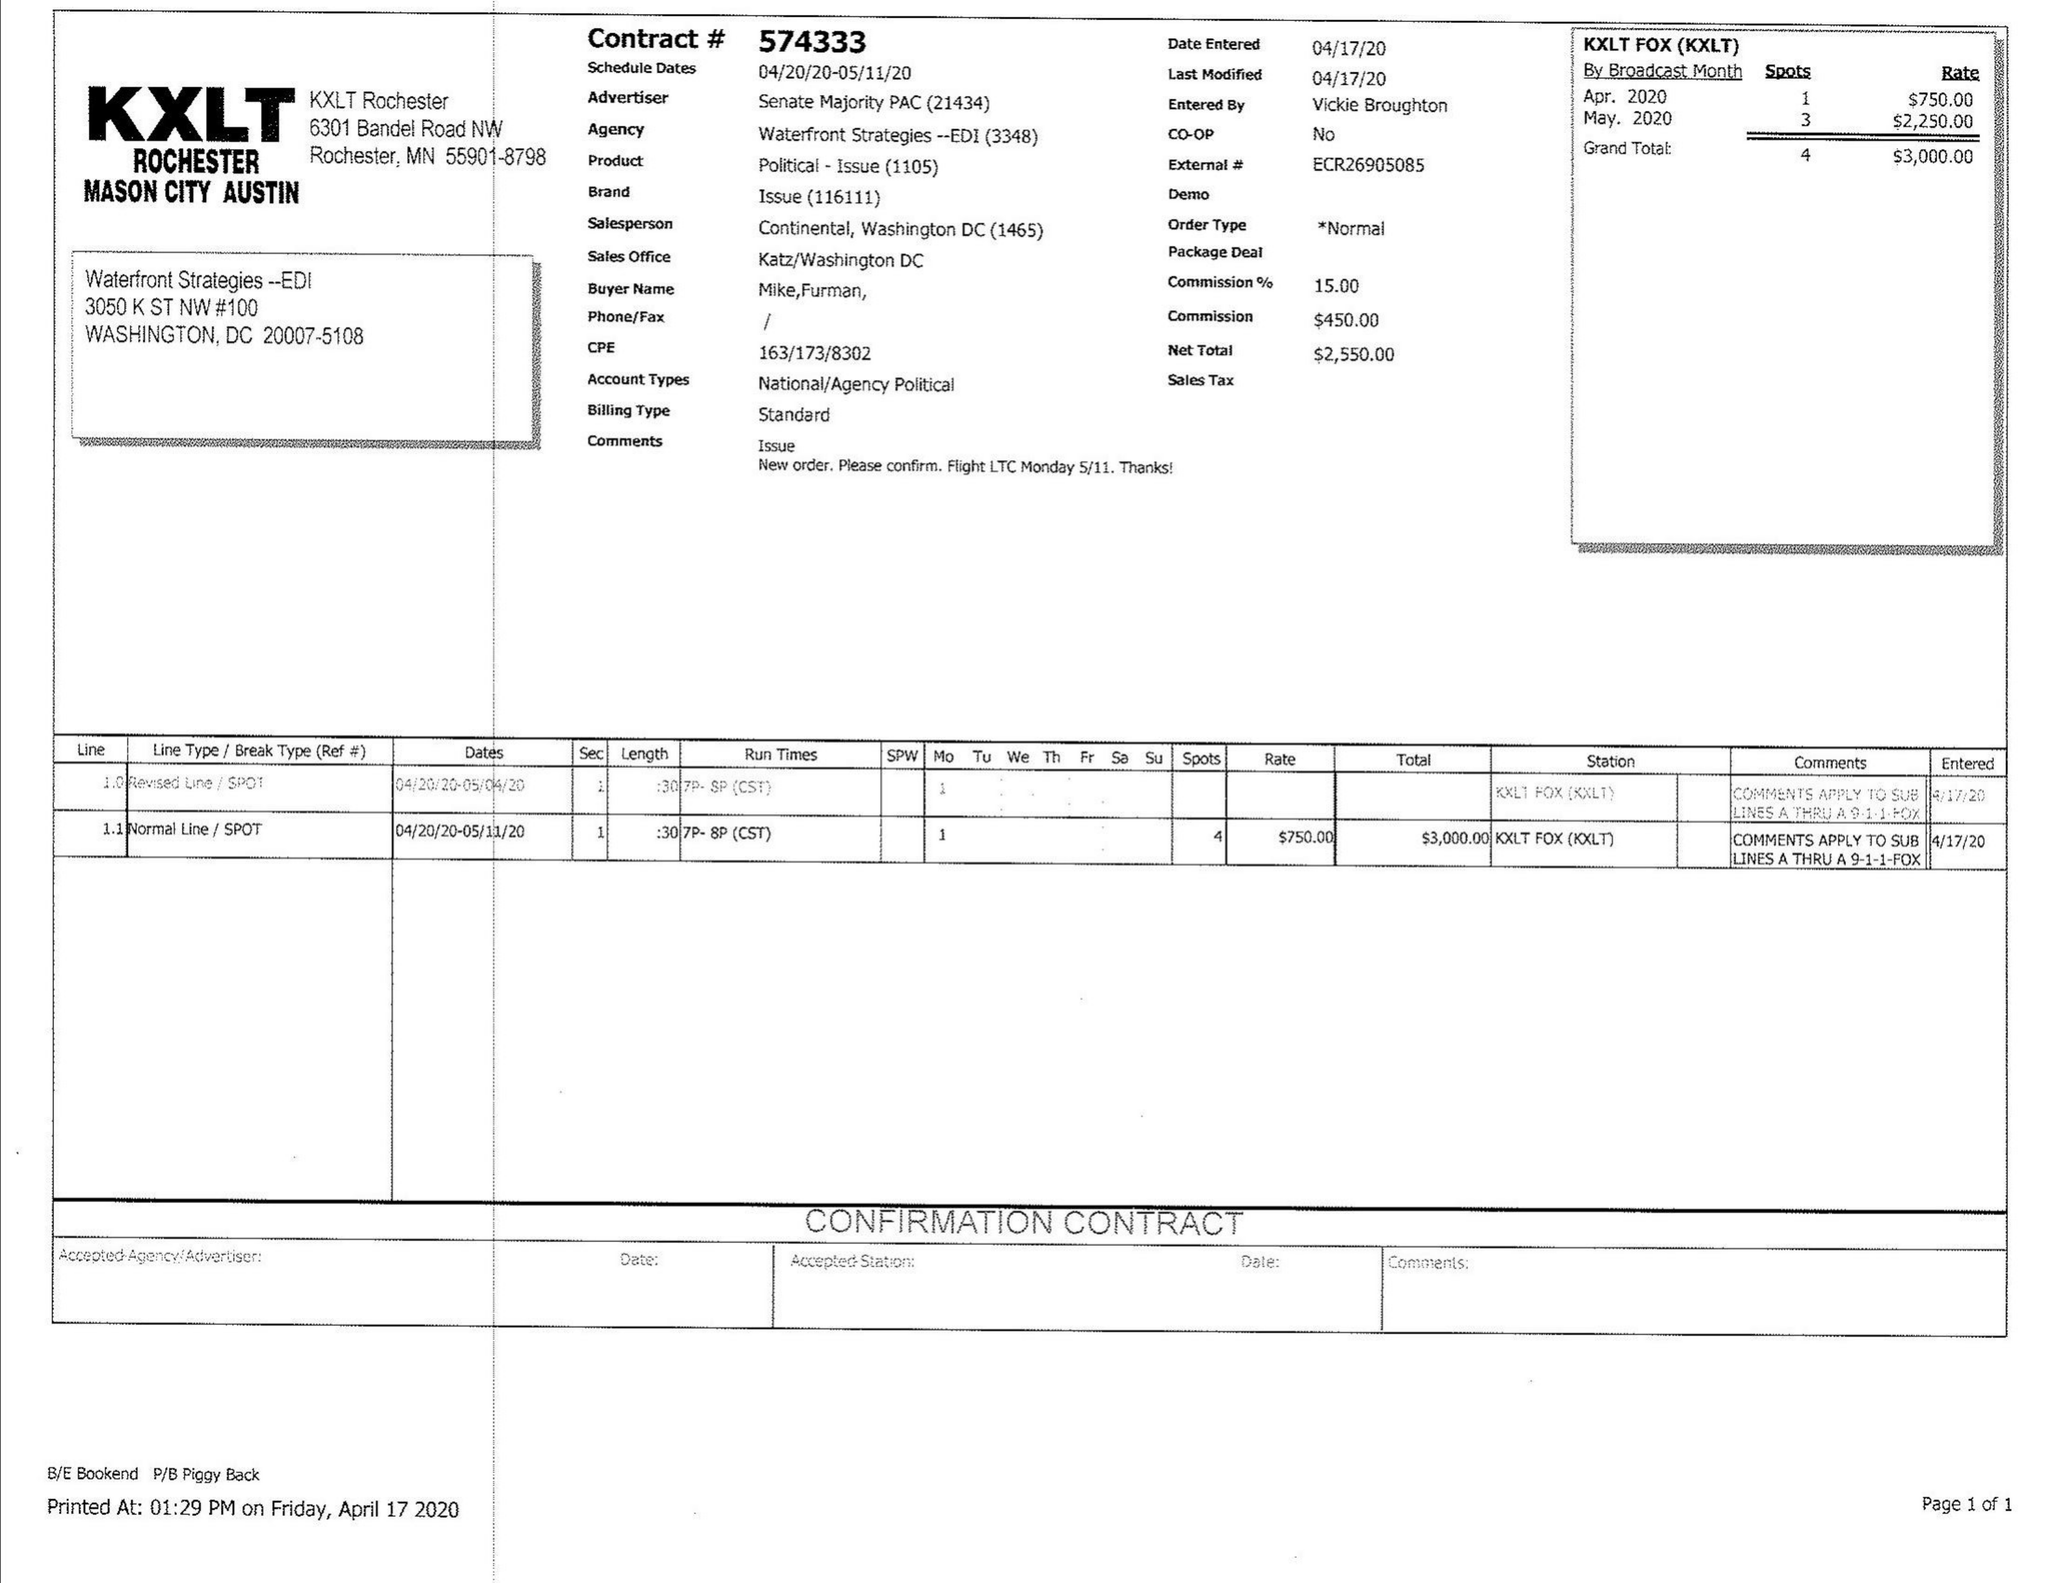What is the value for the flight_from?
Answer the question using a single word or phrase. 04/20/20 